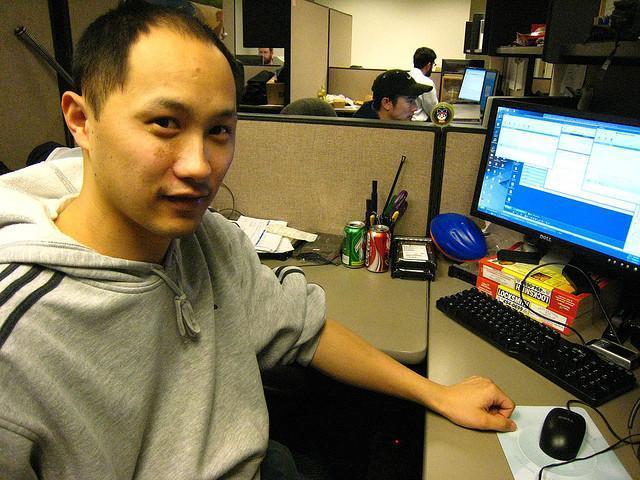How many windows are open on the computer screen?
Give a very brief answer. 4. How many people can be seen?
Give a very brief answer. 2. 